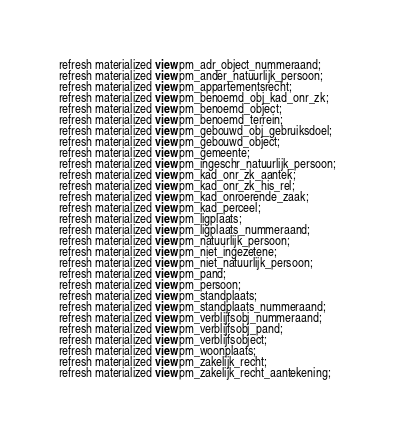<code> <loc_0><loc_0><loc_500><loc_500><_SQL_>refresh materialized view pm_adr_object_nummeraand;
refresh materialized view pm_ander_natuurlijk_persoon;
refresh materialized view pm_appartementsrecht;
refresh materialized view pm_benoemd_obj_kad_onr_zk;
refresh materialized view pm_benoemd_object;
refresh materialized view pm_benoemd_terrein;
refresh materialized view pm_gebouwd_obj_gebruiksdoel;
refresh materialized view pm_gebouwd_object;
refresh materialized view pm_gemeente;
refresh materialized view pm_ingeschr_natuurlijk_persoon;
refresh materialized view pm_kad_onr_zk_aantek;
refresh materialized view pm_kad_onr_zk_his_rel;
refresh materialized view pm_kad_onroerende_zaak;
refresh materialized view pm_kad_perceel;
refresh materialized view pm_ligplaats;
refresh materialized view pm_ligplaats_nummeraand;
refresh materialized view pm_natuurlijk_persoon;
refresh materialized view pm_niet_ingezetene;
refresh materialized view pm_niet_natuurlijk_persoon;
refresh materialized view pm_pand;
refresh materialized view pm_persoon;
refresh materialized view pm_standplaats;
refresh materialized view pm_standplaats_nummeraand;
refresh materialized view pm_verblijfsobj_nummeraand;
refresh materialized view pm_verblijfsobj_pand;
refresh materialized view pm_verblijfsobject;
refresh materialized view pm_woonplaats;
refresh materialized view pm_zakelijk_recht;
refresh materialized view pm_zakelijk_recht_aantekening;</code> 